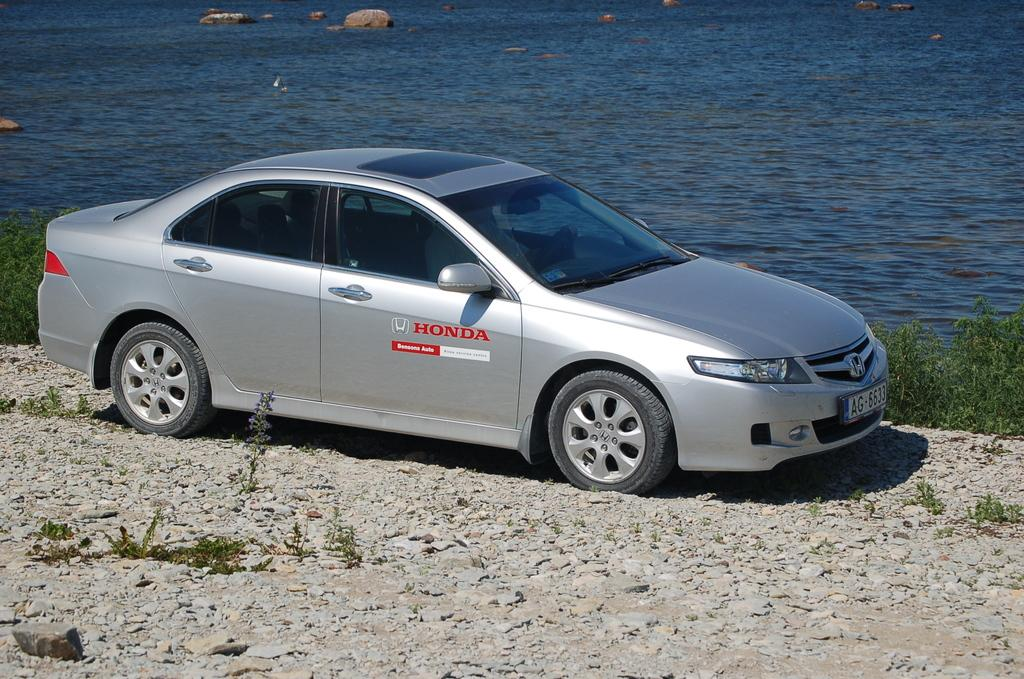What type of vehicle is present in the image? There is a car on the surface in the image. What other objects can be seen on the surface? There are stones visible in the image. What type of vegetation is present in the image? There are plants in the image. What can be seen in the background of the image? There is water and rocks visible in the background of the image. What rule is being enforced by the tramp in the image? There is no tramp present in the image, and therefore no rule enforcement can be observed. 